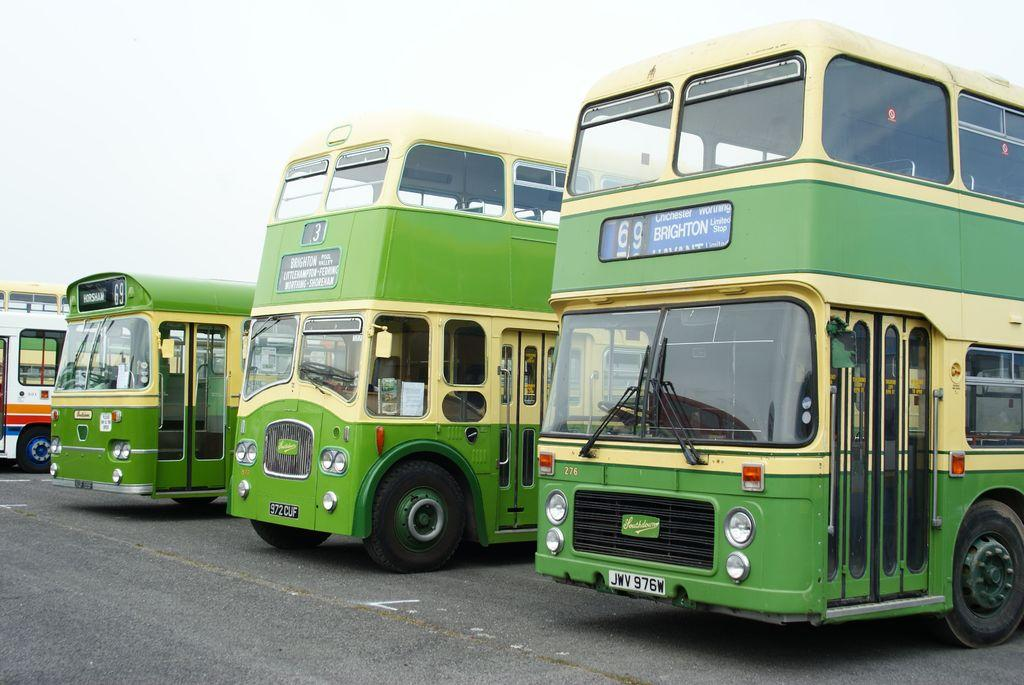<image>
Present a compact description of the photo's key features. A row of buses, the closest one is the number 69 to Brighton. 